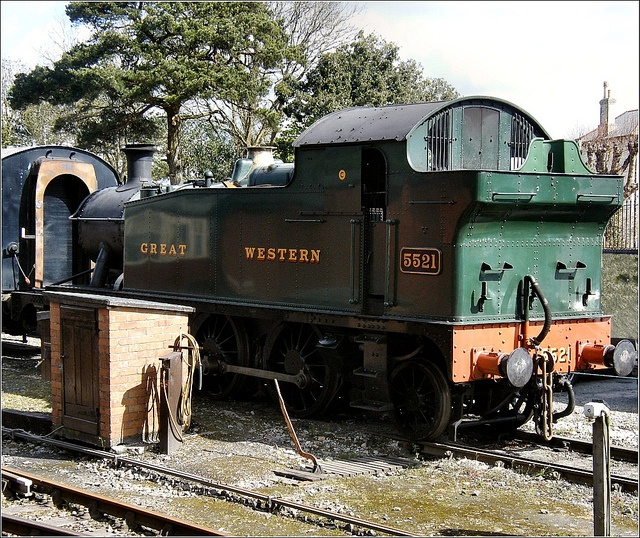Describe the objects in this image and their specific colors. I can see a train in black, darkgray, gray, and teal tones in this image. 